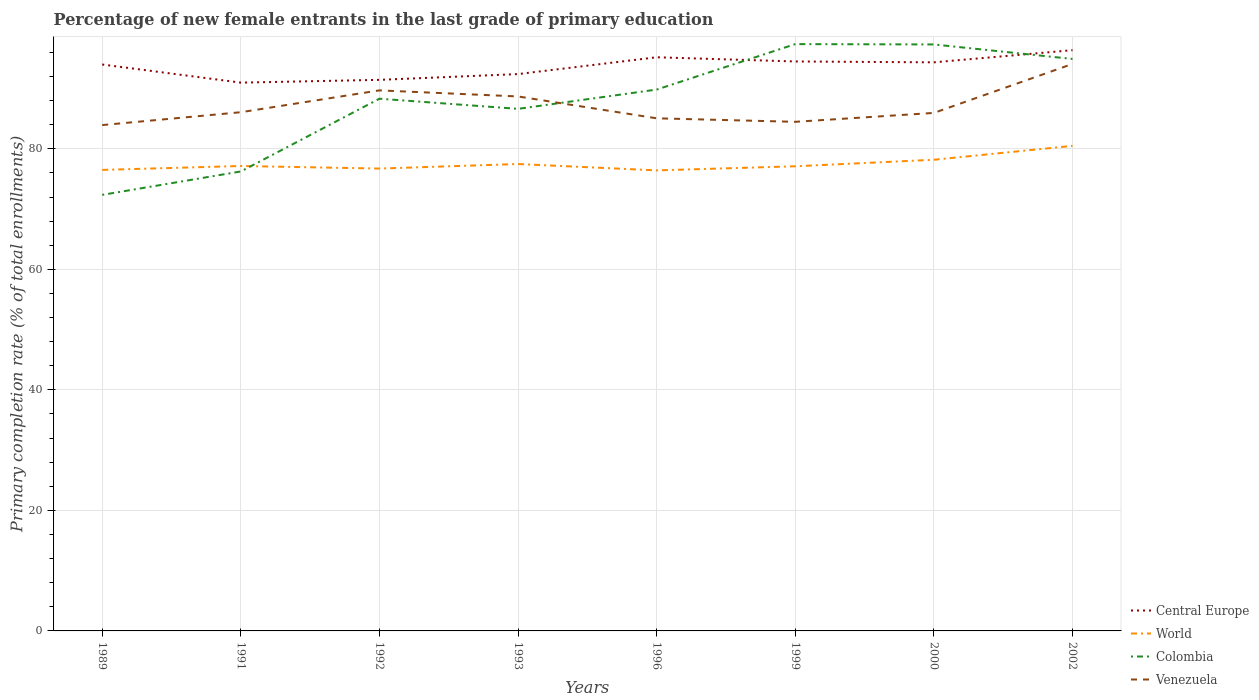How many different coloured lines are there?
Your response must be concise. 4. Across all years, what is the maximum percentage of new female entrants in Central Europe?
Your response must be concise. 90.98. In which year was the percentage of new female entrants in Venezuela maximum?
Your answer should be compact. 1989. What is the total percentage of new female entrants in Central Europe in the graph?
Make the answer very short. 0.7. What is the difference between the highest and the second highest percentage of new female entrants in Central Europe?
Your answer should be very brief. 5.39. What is the difference between the highest and the lowest percentage of new female entrants in Central Europe?
Keep it short and to the point. 5. Is the percentage of new female entrants in Central Europe strictly greater than the percentage of new female entrants in World over the years?
Ensure brevity in your answer.  No. How many years are there in the graph?
Provide a succinct answer. 8. Are the values on the major ticks of Y-axis written in scientific E-notation?
Offer a terse response. No. Does the graph contain any zero values?
Give a very brief answer. No. Does the graph contain grids?
Keep it short and to the point. Yes. How many legend labels are there?
Make the answer very short. 4. How are the legend labels stacked?
Keep it short and to the point. Vertical. What is the title of the graph?
Provide a succinct answer. Percentage of new female entrants in the last grade of primary education. What is the label or title of the X-axis?
Provide a succinct answer. Years. What is the label or title of the Y-axis?
Give a very brief answer. Primary completion rate (% of total enrollments). What is the Primary completion rate (% of total enrollments) in Central Europe in 1989?
Make the answer very short. 93.98. What is the Primary completion rate (% of total enrollments) in World in 1989?
Provide a short and direct response. 76.5. What is the Primary completion rate (% of total enrollments) of Colombia in 1989?
Give a very brief answer. 72.35. What is the Primary completion rate (% of total enrollments) of Venezuela in 1989?
Your response must be concise. 83.93. What is the Primary completion rate (% of total enrollments) in Central Europe in 1991?
Provide a succinct answer. 90.98. What is the Primary completion rate (% of total enrollments) in World in 1991?
Your answer should be very brief. 77.14. What is the Primary completion rate (% of total enrollments) in Colombia in 1991?
Provide a succinct answer. 76.24. What is the Primary completion rate (% of total enrollments) of Venezuela in 1991?
Give a very brief answer. 86.07. What is the Primary completion rate (% of total enrollments) in Central Europe in 1992?
Provide a short and direct response. 91.44. What is the Primary completion rate (% of total enrollments) of World in 1992?
Your answer should be very brief. 76.72. What is the Primary completion rate (% of total enrollments) of Colombia in 1992?
Your response must be concise. 88.31. What is the Primary completion rate (% of total enrollments) of Venezuela in 1992?
Give a very brief answer. 89.69. What is the Primary completion rate (% of total enrollments) of Central Europe in 1993?
Make the answer very short. 92.4. What is the Primary completion rate (% of total enrollments) of World in 1993?
Your answer should be very brief. 77.47. What is the Primary completion rate (% of total enrollments) in Colombia in 1993?
Your response must be concise. 86.63. What is the Primary completion rate (% of total enrollments) in Venezuela in 1993?
Your response must be concise. 88.68. What is the Primary completion rate (% of total enrollments) in Central Europe in 1996?
Offer a very short reply. 95.19. What is the Primary completion rate (% of total enrollments) in World in 1996?
Make the answer very short. 76.42. What is the Primary completion rate (% of total enrollments) of Colombia in 1996?
Make the answer very short. 89.82. What is the Primary completion rate (% of total enrollments) of Venezuela in 1996?
Provide a short and direct response. 85.06. What is the Primary completion rate (% of total enrollments) in Central Europe in 1999?
Your response must be concise. 94.49. What is the Primary completion rate (% of total enrollments) of World in 1999?
Provide a succinct answer. 77.1. What is the Primary completion rate (% of total enrollments) in Colombia in 1999?
Offer a very short reply. 97.37. What is the Primary completion rate (% of total enrollments) in Venezuela in 1999?
Provide a short and direct response. 84.48. What is the Primary completion rate (% of total enrollments) in Central Europe in 2000?
Provide a short and direct response. 94.35. What is the Primary completion rate (% of total enrollments) of World in 2000?
Offer a terse response. 78.18. What is the Primary completion rate (% of total enrollments) of Colombia in 2000?
Ensure brevity in your answer.  97.31. What is the Primary completion rate (% of total enrollments) of Venezuela in 2000?
Your answer should be compact. 85.95. What is the Primary completion rate (% of total enrollments) of Central Europe in 2002?
Provide a short and direct response. 96.36. What is the Primary completion rate (% of total enrollments) in World in 2002?
Offer a terse response. 80.49. What is the Primary completion rate (% of total enrollments) of Colombia in 2002?
Make the answer very short. 94.91. What is the Primary completion rate (% of total enrollments) in Venezuela in 2002?
Your answer should be compact. 94.08. Across all years, what is the maximum Primary completion rate (% of total enrollments) in Central Europe?
Offer a very short reply. 96.36. Across all years, what is the maximum Primary completion rate (% of total enrollments) of World?
Provide a short and direct response. 80.49. Across all years, what is the maximum Primary completion rate (% of total enrollments) of Colombia?
Provide a short and direct response. 97.37. Across all years, what is the maximum Primary completion rate (% of total enrollments) in Venezuela?
Provide a succinct answer. 94.08. Across all years, what is the minimum Primary completion rate (% of total enrollments) of Central Europe?
Your response must be concise. 90.98. Across all years, what is the minimum Primary completion rate (% of total enrollments) of World?
Give a very brief answer. 76.42. Across all years, what is the minimum Primary completion rate (% of total enrollments) in Colombia?
Offer a very short reply. 72.35. Across all years, what is the minimum Primary completion rate (% of total enrollments) of Venezuela?
Provide a succinct answer. 83.93. What is the total Primary completion rate (% of total enrollments) of Central Europe in the graph?
Make the answer very short. 749.18. What is the total Primary completion rate (% of total enrollments) in World in the graph?
Make the answer very short. 620.01. What is the total Primary completion rate (% of total enrollments) of Colombia in the graph?
Offer a terse response. 702.95. What is the total Primary completion rate (% of total enrollments) of Venezuela in the graph?
Your response must be concise. 697.95. What is the difference between the Primary completion rate (% of total enrollments) of Central Europe in 1989 and that in 1991?
Give a very brief answer. 3.01. What is the difference between the Primary completion rate (% of total enrollments) in World in 1989 and that in 1991?
Offer a very short reply. -0.65. What is the difference between the Primary completion rate (% of total enrollments) of Colombia in 1989 and that in 1991?
Give a very brief answer. -3.88. What is the difference between the Primary completion rate (% of total enrollments) in Venezuela in 1989 and that in 1991?
Ensure brevity in your answer.  -2.13. What is the difference between the Primary completion rate (% of total enrollments) of Central Europe in 1989 and that in 1992?
Your response must be concise. 2.54. What is the difference between the Primary completion rate (% of total enrollments) in World in 1989 and that in 1992?
Your response must be concise. -0.22. What is the difference between the Primary completion rate (% of total enrollments) of Colombia in 1989 and that in 1992?
Your response must be concise. -15.96. What is the difference between the Primary completion rate (% of total enrollments) in Venezuela in 1989 and that in 1992?
Keep it short and to the point. -5.76. What is the difference between the Primary completion rate (% of total enrollments) in Central Europe in 1989 and that in 1993?
Keep it short and to the point. 1.59. What is the difference between the Primary completion rate (% of total enrollments) in World in 1989 and that in 1993?
Provide a succinct answer. -0.98. What is the difference between the Primary completion rate (% of total enrollments) in Colombia in 1989 and that in 1993?
Give a very brief answer. -14.27. What is the difference between the Primary completion rate (% of total enrollments) in Venezuela in 1989 and that in 1993?
Your response must be concise. -4.75. What is the difference between the Primary completion rate (% of total enrollments) of Central Europe in 1989 and that in 1996?
Ensure brevity in your answer.  -1.2. What is the difference between the Primary completion rate (% of total enrollments) in World in 1989 and that in 1996?
Give a very brief answer. 0.08. What is the difference between the Primary completion rate (% of total enrollments) in Colombia in 1989 and that in 1996?
Your answer should be very brief. -17.47. What is the difference between the Primary completion rate (% of total enrollments) in Venezuela in 1989 and that in 1996?
Keep it short and to the point. -1.12. What is the difference between the Primary completion rate (% of total enrollments) in Central Europe in 1989 and that in 1999?
Ensure brevity in your answer.  -0.51. What is the difference between the Primary completion rate (% of total enrollments) of World in 1989 and that in 1999?
Offer a terse response. -0.6. What is the difference between the Primary completion rate (% of total enrollments) in Colombia in 1989 and that in 1999?
Your answer should be very brief. -25.01. What is the difference between the Primary completion rate (% of total enrollments) in Venezuela in 1989 and that in 1999?
Provide a succinct answer. -0.54. What is the difference between the Primary completion rate (% of total enrollments) in Central Europe in 1989 and that in 2000?
Offer a terse response. -0.36. What is the difference between the Primary completion rate (% of total enrollments) in World in 1989 and that in 2000?
Give a very brief answer. -1.68. What is the difference between the Primary completion rate (% of total enrollments) of Colombia in 1989 and that in 2000?
Provide a succinct answer. -24.96. What is the difference between the Primary completion rate (% of total enrollments) of Venezuela in 1989 and that in 2000?
Give a very brief answer. -2.02. What is the difference between the Primary completion rate (% of total enrollments) in Central Europe in 1989 and that in 2002?
Keep it short and to the point. -2.38. What is the difference between the Primary completion rate (% of total enrollments) in World in 1989 and that in 2002?
Provide a succinct answer. -3.99. What is the difference between the Primary completion rate (% of total enrollments) of Colombia in 1989 and that in 2002?
Offer a terse response. -22.55. What is the difference between the Primary completion rate (% of total enrollments) of Venezuela in 1989 and that in 2002?
Offer a terse response. -10.14. What is the difference between the Primary completion rate (% of total enrollments) of Central Europe in 1991 and that in 1992?
Your answer should be compact. -0.46. What is the difference between the Primary completion rate (% of total enrollments) of World in 1991 and that in 1992?
Offer a terse response. 0.43. What is the difference between the Primary completion rate (% of total enrollments) in Colombia in 1991 and that in 1992?
Give a very brief answer. -12.07. What is the difference between the Primary completion rate (% of total enrollments) of Venezuela in 1991 and that in 1992?
Offer a terse response. -3.62. What is the difference between the Primary completion rate (% of total enrollments) in Central Europe in 1991 and that in 1993?
Keep it short and to the point. -1.42. What is the difference between the Primary completion rate (% of total enrollments) in World in 1991 and that in 1993?
Provide a short and direct response. -0.33. What is the difference between the Primary completion rate (% of total enrollments) of Colombia in 1991 and that in 1993?
Keep it short and to the point. -10.39. What is the difference between the Primary completion rate (% of total enrollments) in Venezuela in 1991 and that in 1993?
Provide a succinct answer. -2.61. What is the difference between the Primary completion rate (% of total enrollments) in Central Europe in 1991 and that in 1996?
Your answer should be very brief. -4.21. What is the difference between the Primary completion rate (% of total enrollments) of World in 1991 and that in 1996?
Keep it short and to the point. 0.73. What is the difference between the Primary completion rate (% of total enrollments) of Colombia in 1991 and that in 1996?
Keep it short and to the point. -13.58. What is the difference between the Primary completion rate (% of total enrollments) of Central Europe in 1991 and that in 1999?
Make the answer very short. -3.51. What is the difference between the Primary completion rate (% of total enrollments) in World in 1991 and that in 1999?
Make the answer very short. 0.05. What is the difference between the Primary completion rate (% of total enrollments) of Colombia in 1991 and that in 1999?
Offer a terse response. -21.13. What is the difference between the Primary completion rate (% of total enrollments) in Venezuela in 1991 and that in 1999?
Offer a terse response. 1.59. What is the difference between the Primary completion rate (% of total enrollments) of Central Europe in 1991 and that in 2000?
Provide a succinct answer. -3.37. What is the difference between the Primary completion rate (% of total enrollments) in World in 1991 and that in 2000?
Your answer should be compact. -1.04. What is the difference between the Primary completion rate (% of total enrollments) in Colombia in 1991 and that in 2000?
Give a very brief answer. -21.07. What is the difference between the Primary completion rate (% of total enrollments) of Venezuela in 1991 and that in 2000?
Give a very brief answer. 0.12. What is the difference between the Primary completion rate (% of total enrollments) in Central Europe in 1991 and that in 2002?
Give a very brief answer. -5.39. What is the difference between the Primary completion rate (% of total enrollments) in World in 1991 and that in 2002?
Offer a very short reply. -3.34. What is the difference between the Primary completion rate (% of total enrollments) in Colombia in 1991 and that in 2002?
Provide a succinct answer. -18.67. What is the difference between the Primary completion rate (% of total enrollments) in Venezuela in 1991 and that in 2002?
Your answer should be compact. -8.01. What is the difference between the Primary completion rate (% of total enrollments) of Central Europe in 1992 and that in 1993?
Provide a short and direct response. -0.96. What is the difference between the Primary completion rate (% of total enrollments) in World in 1992 and that in 1993?
Your response must be concise. -0.75. What is the difference between the Primary completion rate (% of total enrollments) of Colombia in 1992 and that in 1993?
Provide a short and direct response. 1.68. What is the difference between the Primary completion rate (% of total enrollments) in Venezuela in 1992 and that in 1993?
Provide a succinct answer. 1.01. What is the difference between the Primary completion rate (% of total enrollments) in Central Europe in 1992 and that in 1996?
Provide a short and direct response. -3.75. What is the difference between the Primary completion rate (% of total enrollments) of World in 1992 and that in 1996?
Give a very brief answer. 0.3. What is the difference between the Primary completion rate (% of total enrollments) in Colombia in 1992 and that in 1996?
Provide a succinct answer. -1.51. What is the difference between the Primary completion rate (% of total enrollments) in Venezuela in 1992 and that in 1996?
Your answer should be very brief. 4.63. What is the difference between the Primary completion rate (% of total enrollments) of Central Europe in 1992 and that in 1999?
Provide a succinct answer. -3.05. What is the difference between the Primary completion rate (% of total enrollments) in World in 1992 and that in 1999?
Make the answer very short. -0.38. What is the difference between the Primary completion rate (% of total enrollments) of Colombia in 1992 and that in 1999?
Your answer should be compact. -9.06. What is the difference between the Primary completion rate (% of total enrollments) in Venezuela in 1992 and that in 1999?
Your response must be concise. 5.22. What is the difference between the Primary completion rate (% of total enrollments) of Central Europe in 1992 and that in 2000?
Your response must be concise. -2.91. What is the difference between the Primary completion rate (% of total enrollments) in World in 1992 and that in 2000?
Your answer should be very brief. -1.46. What is the difference between the Primary completion rate (% of total enrollments) of Colombia in 1992 and that in 2000?
Provide a succinct answer. -9. What is the difference between the Primary completion rate (% of total enrollments) of Venezuela in 1992 and that in 2000?
Offer a very short reply. 3.74. What is the difference between the Primary completion rate (% of total enrollments) of Central Europe in 1992 and that in 2002?
Your response must be concise. -4.92. What is the difference between the Primary completion rate (% of total enrollments) in World in 1992 and that in 2002?
Your answer should be compact. -3.77. What is the difference between the Primary completion rate (% of total enrollments) of Colombia in 1992 and that in 2002?
Make the answer very short. -6.6. What is the difference between the Primary completion rate (% of total enrollments) of Venezuela in 1992 and that in 2002?
Offer a very short reply. -4.39. What is the difference between the Primary completion rate (% of total enrollments) of Central Europe in 1993 and that in 1996?
Provide a succinct answer. -2.79. What is the difference between the Primary completion rate (% of total enrollments) in World in 1993 and that in 1996?
Provide a succinct answer. 1.05. What is the difference between the Primary completion rate (% of total enrollments) in Colombia in 1993 and that in 1996?
Give a very brief answer. -3.2. What is the difference between the Primary completion rate (% of total enrollments) of Venezuela in 1993 and that in 1996?
Offer a very short reply. 3.62. What is the difference between the Primary completion rate (% of total enrollments) in Central Europe in 1993 and that in 1999?
Your answer should be very brief. -2.09. What is the difference between the Primary completion rate (% of total enrollments) of World in 1993 and that in 1999?
Your answer should be very brief. 0.37. What is the difference between the Primary completion rate (% of total enrollments) in Colombia in 1993 and that in 1999?
Offer a terse response. -10.74. What is the difference between the Primary completion rate (% of total enrollments) of Venezuela in 1993 and that in 1999?
Keep it short and to the point. 4.21. What is the difference between the Primary completion rate (% of total enrollments) of Central Europe in 1993 and that in 2000?
Your answer should be compact. -1.95. What is the difference between the Primary completion rate (% of total enrollments) in World in 1993 and that in 2000?
Your answer should be very brief. -0.71. What is the difference between the Primary completion rate (% of total enrollments) in Colombia in 1993 and that in 2000?
Keep it short and to the point. -10.69. What is the difference between the Primary completion rate (% of total enrollments) in Venezuela in 1993 and that in 2000?
Offer a terse response. 2.73. What is the difference between the Primary completion rate (% of total enrollments) in Central Europe in 1993 and that in 2002?
Keep it short and to the point. -3.97. What is the difference between the Primary completion rate (% of total enrollments) of World in 1993 and that in 2002?
Offer a very short reply. -3.02. What is the difference between the Primary completion rate (% of total enrollments) in Colombia in 1993 and that in 2002?
Your answer should be very brief. -8.28. What is the difference between the Primary completion rate (% of total enrollments) in Venezuela in 1993 and that in 2002?
Your answer should be very brief. -5.4. What is the difference between the Primary completion rate (% of total enrollments) of Central Europe in 1996 and that in 1999?
Make the answer very short. 0.7. What is the difference between the Primary completion rate (% of total enrollments) in World in 1996 and that in 1999?
Give a very brief answer. -0.68. What is the difference between the Primary completion rate (% of total enrollments) in Colombia in 1996 and that in 1999?
Make the answer very short. -7.54. What is the difference between the Primary completion rate (% of total enrollments) in Venezuela in 1996 and that in 1999?
Offer a terse response. 0.58. What is the difference between the Primary completion rate (% of total enrollments) of Central Europe in 1996 and that in 2000?
Offer a terse response. 0.84. What is the difference between the Primary completion rate (% of total enrollments) of World in 1996 and that in 2000?
Offer a terse response. -1.76. What is the difference between the Primary completion rate (% of total enrollments) of Colombia in 1996 and that in 2000?
Offer a terse response. -7.49. What is the difference between the Primary completion rate (% of total enrollments) in Venezuela in 1996 and that in 2000?
Ensure brevity in your answer.  -0.89. What is the difference between the Primary completion rate (% of total enrollments) in Central Europe in 1996 and that in 2002?
Offer a very short reply. -1.18. What is the difference between the Primary completion rate (% of total enrollments) of World in 1996 and that in 2002?
Make the answer very short. -4.07. What is the difference between the Primary completion rate (% of total enrollments) of Colombia in 1996 and that in 2002?
Ensure brevity in your answer.  -5.08. What is the difference between the Primary completion rate (% of total enrollments) of Venezuela in 1996 and that in 2002?
Provide a short and direct response. -9.02. What is the difference between the Primary completion rate (% of total enrollments) in Central Europe in 1999 and that in 2000?
Ensure brevity in your answer.  0.14. What is the difference between the Primary completion rate (% of total enrollments) in World in 1999 and that in 2000?
Give a very brief answer. -1.08. What is the difference between the Primary completion rate (% of total enrollments) of Colombia in 1999 and that in 2000?
Offer a very short reply. 0.06. What is the difference between the Primary completion rate (% of total enrollments) in Venezuela in 1999 and that in 2000?
Your response must be concise. -1.48. What is the difference between the Primary completion rate (% of total enrollments) in Central Europe in 1999 and that in 2002?
Offer a terse response. -1.87. What is the difference between the Primary completion rate (% of total enrollments) in World in 1999 and that in 2002?
Make the answer very short. -3.39. What is the difference between the Primary completion rate (% of total enrollments) of Colombia in 1999 and that in 2002?
Your answer should be very brief. 2.46. What is the difference between the Primary completion rate (% of total enrollments) in Venezuela in 1999 and that in 2002?
Offer a terse response. -9.6. What is the difference between the Primary completion rate (% of total enrollments) in Central Europe in 2000 and that in 2002?
Your answer should be compact. -2.02. What is the difference between the Primary completion rate (% of total enrollments) in World in 2000 and that in 2002?
Give a very brief answer. -2.31. What is the difference between the Primary completion rate (% of total enrollments) of Colombia in 2000 and that in 2002?
Make the answer very short. 2.4. What is the difference between the Primary completion rate (% of total enrollments) in Venezuela in 2000 and that in 2002?
Keep it short and to the point. -8.12. What is the difference between the Primary completion rate (% of total enrollments) in Central Europe in 1989 and the Primary completion rate (% of total enrollments) in World in 1991?
Your answer should be compact. 16.84. What is the difference between the Primary completion rate (% of total enrollments) in Central Europe in 1989 and the Primary completion rate (% of total enrollments) in Colombia in 1991?
Make the answer very short. 17.74. What is the difference between the Primary completion rate (% of total enrollments) in Central Europe in 1989 and the Primary completion rate (% of total enrollments) in Venezuela in 1991?
Your response must be concise. 7.91. What is the difference between the Primary completion rate (% of total enrollments) in World in 1989 and the Primary completion rate (% of total enrollments) in Colombia in 1991?
Your answer should be very brief. 0.26. What is the difference between the Primary completion rate (% of total enrollments) in World in 1989 and the Primary completion rate (% of total enrollments) in Venezuela in 1991?
Your answer should be very brief. -9.57. What is the difference between the Primary completion rate (% of total enrollments) in Colombia in 1989 and the Primary completion rate (% of total enrollments) in Venezuela in 1991?
Keep it short and to the point. -13.71. What is the difference between the Primary completion rate (% of total enrollments) of Central Europe in 1989 and the Primary completion rate (% of total enrollments) of World in 1992?
Provide a short and direct response. 17.27. What is the difference between the Primary completion rate (% of total enrollments) in Central Europe in 1989 and the Primary completion rate (% of total enrollments) in Colombia in 1992?
Give a very brief answer. 5.67. What is the difference between the Primary completion rate (% of total enrollments) of Central Europe in 1989 and the Primary completion rate (% of total enrollments) of Venezuela in 1992?
Ensure brevity in your answer.  4.29. What is the difference between the Primary completion rate (% of total enrollments) in World in 1989 and the Primary completion rate (% of total enrollments) in Colombia in 1992?
Provide a succinct answer. -11.82. What is the difference between the Primary completion rate (% of total enrollments) of World in 1989 and the Primary completion rate (% of total enrollments) of Venezuela in 1992?
Provide a succinct answer. -13.2. What is the difference between the Primary completion rate (% of total enrollments) of Colombia in 1989 and the Primary completion rate (% of total enrollments) of Venezuela in 1992?
Provide a short and direct response. -17.34. What is the difference between the Primary completion rate (% of total enrollments) in Central Europe in 1989 and the Primary completion rate (% of total enrollments) in World in 1993?
Keep it short and to the point. 16.51. What is the difference between the Primary completion rate (% of total enrollments) of Central Europe in 1989 and the Primary completion rate (% of total enrollments) of Colombia in 1993?
Keep it short and to the point. 7.36. What is the difference between the Primary completion rate (% of total enrollments) of World in 1989 and the Primary completion rate (% of total enrollments) of Colombia in 1993?
Your response must be concise. -10.13. What is the difference between the Primary completion rate (% of total enrollments) of World in 1989 and the Primary completion rate (% of total enrollments) of Venezuela in 1993?
Your answer should be very brief. -12.19. What is the difference between the Primary completion rate (% of total enrollments) of Colombia in 1989 and the Primary completion rate (% of total enrollments) of Venezuela in 1993?
Offer a terse response. -16.33. What is the difference between the Primary completion rate (% of total enrollments) in Central Europe in 1989 and the Primary completion rate (% of total enrollments) in World in 1996?
Give a very brief answer. 17.57. What is the difference between the Primary completion rate (% of total enrollments) of Central Europe in 1989 and the Primary completion rate (% of total enrollments) of Colombia in 1996?
Your answer should be compact. 4.16. What is the difference between the Primary completion rate (% of total enrollments) in Central Europe in 1989 and the Primary completion rate (% of total enrollments) in Venezuela in 1996?
Your answer should be compact. 8.92. What is the difference between the Primary completion rate (% of total enrollments) of World in 1989 and the Primary completion rate (% of total enrollments) of Colombia in 1996?
Your response must be concise. -13.33. What is the difference between the Primary completion rate (% of total enrollments) in World in 1989 and the Primary completion rate (% of total enrollments) in Venezuela in 1996?
Your answer should be compact. -8.56. What is the difference between the Primary completion rate (% of total enrollments) of Colombia in 1989 and the Primary completion rate (% of total enrollments) of Venezuela in 1996?
Your answer should be compact. -12.7. What is the difference between the Primary completion rate (% of total enrollments) of Central Europe in 1989 and the Primary completion rate (% of total enrollments) of World in 1999?
Provide a succinct answer. 16.89. What is the difference between the Primary completion rate (% of total enrollments) in Central Europe in 1989 and the Primary completion rate (% of total enrollments) in Colombia in 1999?
Give a very brief answer. -3.39. What is the difference between the Primary completion rate (% of total enrollments) of Central Europe in 1989 and the Primary completion rate (% of total enrollments) of Venezuela in 1999?
Your answer should be very brief. 9.51. What is the difference between the Primary completion rate (% of total enrollments) of World in 1989 and the Primary completion rate (% of total enrollments) of Colombia in 1999?
Give a very brief answer. -20.87. What is the difference between the Primary completion rate (% of total enrollments) in World in 1989 and the Primary completion rate (% of total enrollments) in Venezuela in 1999?
Your response must be concise. -7.98. What is the difference between the Primary completion rate (% of total enrollments) of Colombia in 1989 and the Primary completion rate (% of total enrollments) of Venezuela in 1999?
Your response must be concise. -12.12. What is the difference between the Primary completion rate (% of total enrollments) of Central Europe in 1989 and the Primary completion rate (% of total enrollments) of World in 2000?
Your answer should be very brief. 15.8. What is the difference between the Primary completion rate (% of total enrollments) in Central Europe in 1989 and the Primary completion rate (% of total enrollments) in Colombia in 2000?
Offer a terse response. -3.33. What is the difference between the Primary completion rate (% of total enrollments) in Central Europe in 1989 and the Primary completion rate (% of total enrollments) in Venezuela in 2000?
Keep it short and to the point. 8.03. What is the difference between the Primary completion rate (% of total enrollments) in World in 1989 and the Primary completion rate (% of total enrollments) in Colombia in 2000?
Your answer should be compact. -20.82. What is the difference between the Primary completion rate (% of total enrollments) of World in 1989 and the Primary completion rate (% of total enrollments) of Venezuela in 2000?
Your answer should be compact. -9.46. What is the difference between the Primary completion rate (% of total enrollments) in Colombia in 1989 and the Primary completion rate (% of total enrollments) in Venezuela in 2000?
Keep it short and to the point. -13.6. What is the difference between the Primary completion rate (% of total enrollments) in Central Europe in 1989 and the Primary completion rate (% of total enrollments) in World in 2002?
Make the answer very short. 13.5. What is the difference between the Primary completion rate (% of total enrollments) of Central Europe in 1989 and the Primary completion rate (% of total enrollments) of Colombia in 2002?
Ensure brevity in your answer.  -0.92. What is the difference between the Primary completion rate (% of total enrollments) of Central Europe in 1989 and the Primary completion rate (% of total enrollments) of Venezuela in 2002?
Keep it short and to the point. -0.1. What is the difference between the Primary completion rate (% of total enrollments) of World in 1989 and the Primary completion rate (% of total enrollments) of Colombia in 2002?
Provide a succinct answer. -18.41. What is the difference between the Primary completion rate (% of total enrollments) of World in 1989 and the Primary completion rate (% of total enrollments) of Venezuela in 2002?
Provide a succinct answer. -17.58. What is the difference between the Primary completion rate (% of total enrollments) of Colombia in 1989 and the Primary completion rate (% of total enrollments) of Venezuela in 2002?
Provide a short and direct response. -21.72. What is the difference between the Primary completion rate (% of total enrollments) in Central Europe in 1991 and the Primary completion rate (% of total enrollments) in World in 1992?
Your response must be concise. 14.26. What is the difference between the Primary completion rate (% of total enrollments) of Central Europe in 1991 and the Primary completion rate (% of total enrollments) of Colombia in 1992?
Your answer should be compact. 2.67. What is the difference between the Primary completion rate (% of total enrollments) in Central Europe in 1991 and the Primary completion rate (% of total enrollments) in Venezuela in 1992?
Make the answer very short. 1.28. What is the difference between the Primary completion rate (% of total enrollments) of World in 1991 and the Primary completion rate (% of total enrollments) of Colombia in 1992?
Give a very brief answer. -11.17. What is the difference between the Primary completion rate (% of total enrollments) in World in 1991 and the Primary completion rate (% of total enrollments) in Venezuela in 1992?
Ensure brevity in your answer.  -12.55. What is the difference between the Primary completion rate (% of total enrollments) of Colombia in 1991 and the Primary completion rate (% of total enrollments) of Venezuela in 1992?
Provide a succinct answer. -13.45. What is the difference between the Primary completion rate (% of total enrollments) of Central Europe in 1991 and the Primary completion rate (% of total enrollments) of World in 1993?
Offer a terse response. 13.51. What is the difference between the Primary completion rate (% of total enrollments) in Central Europe in 1991 and the Primary completion rate (% of total enrollments) in Colombia in 1993?
Your answer should be very brief. 4.35. What is the difference between the Primary completion rate (% of total enrollments) in Central Europe in 1991 and the Primary completion rate (% of total enrollments) in Venezuela in 1993?
Give a very brief answer. 2.29. What is the difference between the Primary completion rate (% of total enrollments) in World in 1991 and the Primary completion rate (% of total enrollments) in Colombia in 1993?
Ensure brevity in your answer.  -9.48. What is the difference between the Primary completion rate (% of total enrollments) in World in 1991 and the Primary completion rate (% of total enrollments) in Venezuela in 1993?
Make the answer very short. -11.54. What is the difference between the Primary completion rate (% of total enrollments) in Colombia in 1991 and the Primary completion rate (% of total enrollments) in Venezuela in 1993?
Provide a succinct answer. -12.44. What is the difference between the Primary completion rate (% of total enrollments) in Central Europe in 1991 and the Primary completion rate (% of total enrollments) in World in 1996?
Your answer should be very brief. 14.56. What is the difference between the Primary completion rate (% of total enrollments) of Central Europe in 1991 and the Primary completion rate (% of total enrollments) of Colombia in 1996?
Keep it short and to the point. 1.15. What is the difference between the Primary completion rate (% of total enrollments) of Central Europe in 1991 and the Primary completion rate (% of total enrollments) of Venezuela in 1996?
Your answer should be compact. 5.92. What is the difference between the Primary completion rate (% of total enrollments) in World in 1991 and the Primary completion rate (% of total enrollments) in Colombia in 1996?
Your answer should be compact. -12.68. What is the difference between the Primary completion rate (% of total enrollments) in World in 1991 and the Primary completion rate (% of total enrollments) in Venezuela in 1996?
Your answer should be very brief. -7.91. What is the difference between the Primary completion rate (% of total enrollments) of Colombia in 1991 and the Primary completion rate (% of total enrollments) of Venezuela in 1996?
Keep it short and to the point. -8.82. What is the difference between the Primary completion rate (% of total enrollments) in Central Europe in 1991 and the Primary completion rate (% of total enrollments) in World in 1999?
Offer a terse response. 13.88. What is the difference between the Primary completion rate (% of total enrollments) in Central Europe in 1991 and the Primary completion rate (% of total enrollments) in Colombia in 1999?
Provide a succinct answer. -6.39. What is the difference between the Primary completion rate (% of total enrollments) in Central Europe in 1991 and the Primary completion rate (% of total enrollments) in Venezuela in 1999?
Provide a succinct answer. 6.5. What is the difference between the Primary completion rate (% of total enrollments) in World in 1991 and the Primary completion rate (% of total enrollments) in Colombia in 1999?
Your answer should be compact. -20.22. What is the difference between the Primary completion rate (% of total enrollments) of World in 1991 and the Primary completion rate (% of total enrollments) of Venezuela in 1999?
Make the answer very short. -7.33. What is the difference between the Primary completion rate (% of total enrollments) in Colombia in 1991 and the Primary completion rate (% of total enrollments) in Venezuela in 1999?
Ensure brevity in your answer.  -8.24. What is the difference between the Primary completion rate (% of total enrollments) of Central Europe in 1991 and the Primary completion rate (% of total enrollments) of World in 2000?
Your response must be concise. 12.8. What is the difference between the Primary completion rate (% of total enrollments) in Central Europe in 1991 and the Primary completion rate (% of total enrollments) in Colombia in 2000?
Make the answer very short. -6.34. What is the difference between the Primary completion rate (% of total enrollments) in Central Europe in 1991 and the Primary completion rate (% of total enrollments) in Venezuela in 2000?
Give a very brief answer. 5.02. What is the difference between the Primary completion rate (% of total enrollments) of World in 1991 and the Primary completion rate (% of total enrollments) of Colombia in 2000?
Offer a terse response. -20.17. What is the difference between the Primary completion rate (% of total enrollments) in World in 1991 and the Primary completion rate (% of total enrollments) in Venezuela in 2000?
Keep it short and to the point. -8.81. What is the difference between the Primary completion rate (% of total enrollments) in Colombia in 1991 and the Primary completion rate (% of total enrollments) in Venezuela in 2000?
Your answer should be compact. -9.71. What is the difference between the Primary completion rate (% of total enrollments) of Central Europe in 1991 and the Primary completion rate (% of total enrollments) of World in 2002?
Give a very brief answer. 10.49. What is the difference between the Primary completion rate (% of total enrollments) in Central Europe in 1991 and the Primary completion rate (% of total enrollments) in Colombia in 2002?
Keep it short and to the point. -3.93. What is the difference between the Primary completion rate (% of total enrollments) of Central Europe in 1991 and the Primary completion rate (% of total enrollments) of Venezuela in 2002?
Give a very brief answer. -3.1. What is the difference between the Primary completion rate (% of total enrollments) of World in 1991 and the Primary completion rate (% of total enrollments) of Colombia in 2002?
Your answer should be compact. -17.76. What is the difference between the Primary completion rate (% of total enrollments) in World in 1991 and the Primary completion rate (% of total enrollments) in Venezuela in 2002?
Provide a succinct answer. -16.93. What is the difference between the Primary completion rate (% of total enrollments) in Colombia in 1991 and the Primary completion rate (% of total enrollments) in Venezuela in 2002?
Make the answer very short. -17.84. What is the difference between the Primary completion rate (% of total enrollments) in Central Europe in 1992 and the Primary completion rate (% of total enrollments) in World in 1993?
Your answer should be compact. 13.97. What is the difference between the Primary completion rate (% of total enrollments) in Central Europe in 1992 and the Primary completion rate (% of total enrollments) in Colombia in 1993?
Your response must be concise. 4.81. What is the difference between the Primary completion rate (% of total enrollments) of Central Europe in 1992 and the Primary completion rate (% of total enrollments) of Venezuela in 1993?
Give a very brief answer. 2.76. What is the difference between the Primary completion rate (% of total enrollments) of World in 1992 and the Primary completion rate (% of total enrollments) of Colombia in 1993?
Provide a succinct answer. -9.91. What is the difference between the Primary completion rate (% of total enrollments) in World in 1992 and the Primary completion rate (% of total enrollments) in Venezuela in 1993?
Provide a short and direct response. -11.96. What is the difference between the Primary completion rate (% of total enrollments) of Colombia in 1992 and the Primary completion rate (% of total enrollments) of Venezuela in 1993?
Offer a very short reply. -0.37. What is the difference between the Primary completion rate (% of total enrollments) of Central Europe in 1992 and the Primary completion rate (% of total enrollments) of World in 1996?
Give a very brief answer. 15.02. What is the difference between the Primary completion rate (% of total enrollments) of Central Europe in 1992 and the Primary completion rate (% of total enrollments) of Colombia in 1996?
Keep it short and to the point. 1.62. What is the difference between the Primary completion rate (% of total enrollments) of Central Europe in 1992 and the Primary completion rate (% of total enrollments) of Venezuela in 1996?
Your response must be concise. 6.38. What is the difference between the Primary completion rate (% of total enrollments) of World in 1992 and the Primary completion rate (% of total enrollments) of Colombia in 1996?
Give a very brief answer. -13.11. What is the difference between the Primary completion rate (% of total enrollments) of World in 1992 and the Primary completion rate (% of total enrollments) of Venezuela in 1996?
Provide a short and direct response. -8.34. What is the difference between the Primary completion rate (% of total enrollments) in Colombia in 1992 and the Primary completion rate (% of total enrollments) in Venezuela in 1996?
Your answer should be compact. 3.25. What is the difference between the Primary completion rate (% of total enrollments) of Central Europe in 1992 and the Primary completion rate (% of total enrollments) of World in 1999?
Your answer should be compact. 14.34. What is the difference between the Primary completion rate (% of total enrollments) in Central Europe in 1992 and the Primary completion rate (% of total enrollments) in Colombia in 1999?
Your answer should be compact. -5.93. What is the difference between the Primary completion rate (% of total enrollments) in Central Europe in 1992 and the Primary completion rate (% of total enrollments) in Venezuela in 1999?
Your answer should be very brief. 6.96. What is the difference between the Primary completion rate (% of total enrollments) in World in 1992 and the Primary completion rate (% of total enrollments) in Colombia in 1999?
Your answer should be very brief. -20.65. What is the difference between the Primary completion rate (% of total enrollments) of World in 1992 and the Primary completion rate (% of total enrollments) of Venezuela in 1999?
Offer a terse response. -7.76. What is the difference between the Primary completion rate (% of total enrollments) in Colombia in 1992 and the Primary completion rate (% of total enrollments) in Venezuela in 1999?
Your answer should be very brief. 3.84. What is the difference between the Primary completion rate (% of total enrollments) in Central Europe in 1992 and the Primary completion rate (% of total enrollments) in World in 2000?
Keep it short and to the point. 13.26. What is the difference between the Primary completion rate (% of total enrollments) of Central Europe in 1992 and the Primary completion rate (% of total enrollments) of Colombia in 2000?
Provide a short and direct response. -5.87. What is the difference between the Primary completion rate (% of total enrollments) of Central Europe in 1992 and the Primary completion rate (% of total enrollments) of Venezuela in 2000?
Make the answer very short. 5.49. What is the difference between the Primary completion rate (% of total enrollments) of World in 1992 and the Primary completion rate (% of total enrollments) of Colombia in 2000?
Offer a very short reply. -20.59. What is the difference between the Primary completion rate (% of total enrollments) of World in 1992 and the Primary completion rate (% of total enrollments) of Venezuela in 2000?
Provide a short and direct response. -9.24. What is the difference between the Primary completion rate (% of total enrollments) in Colombia in 1992 and the Primary completion rate (% of total enrollments) in Venezuela in 2000?
Your answer should be very brief. 2.36. What is the difference between the Primary completion rate (% of total enrollments) of Central Europe in 1992 and the Primary completion rate (% of total enrollments) of World in 2002?
Ensure brevity in your answer.  10.95. What is the difference between the Primary completion rate (% of total enrollments) in Central Europe in 1992 and the Primary completion rate (% of total enrollments) in Colombia in 2002?
Make the answer very short. -3.47. What is the difference between the Primary completion rate (% of total enrollments) in Central Europe in 1992 and the Primary completion rate (% of total enrollments) in Venezuela in 2002?
Keep it short and to the point. -2.64. What is the difference between the Primary completion rate (% of total enrollments) of World in 1992 and the Primary completion rate (% of total enrollments) of Colombia in 2002?
Make the answer very short. -18.19. What is the difference between the Primary completion rate (% of total enrollments) in World in 1992 and the Primary completion rate (% of total enrollments) in Venezuela in 2002?
Your answer should be very brief. -17.36. What is the difference between the Primary completion rate (% of total enrollments) of Colombia in 1992 and the Primary completion rate (% of total enrollments) of Venezuela in 2002?
Offer a very short reply. -5.77. What is the difference between the Primary completion rate (% of total enrollments) in Central Europe in 1993 and the Primary completion rate (% of total enrollments) in World in 1996?
Offer a very short reply. 15.98. What is the difference between the Primary completion rate (% of total enrollments) of Central Europe in 1993 and the Primary completion rate (% of total enrollments) of Colombia in 1996?
Offer a terse response. 2.57. What is the difference between the Primary completion rate (% of total enrollments) of Central Europe in 1993 and the Primary completion rate (% of total enrollments) of Venezuela in 1996?
Give a very brief answer. 7.34. What is the difference between the Primary completion rate (% of total enrollments) in World in 1993 and the Primary completion rate (% of total enrollments) in Colombia in 1996?
Your response must be concise. -12.35. What is the difference between the Primary completion rate (% of total enrollments) of World in 1993 and the Primary completion rate (% of total enrollments) of Venezuela in 1996?
Offer a terse response. -7.59. What is the difference between the Primary completion rate (% of total enrollments) in Colombia in 1993 and the Primary completion rate (% of total enrollments) in Venezuela in 1996?
Your answer should be compact. 1.57. What is the difference between the Primary completion rate (% of total enrollments) of Central Europe in 1993 and the Primary completion rate (% of total enrollments) of World in 1999?
Offer a terse response. 15.3. What is the difference between the Primary completion rate (% of total enrollments) in Central Europe in 1993 and the Primary completion rate (% of total enrollments) in Colombia in 1999?
Offer a terse response. -4.97. What is the difference between the Primary completion rate (% of total enrollments) of Central Europe in 1993 and the Primary completion rate (% of total enrollments) of Venezuela in 1999?
Give a very brief answer. 7.92. What is the difference between the Primary completion rate (% of total enrollments) in World in 1993 and the Primary completion rate (% of total enrollments) in Colombia in 1999?
Give a very brief answer. -19.9. What is the difference between the Primary completion rate (% of total enrollments) of World in 1993 and the Primary completion rate (% of total enrollments) of Venezuela in 1999?
Your answer should be very brief. -7. What is the difference between the Primary completion rate (% of total enrollments) in Colombia in 1993 and the Primary completion rate (% of total enrollments) in Venezuela in 1999?
Your answer should be compact. 2.15. What is the difference between the Primary completion rate (% of total enrollments) in Central Europe in 1993 and the Primary completion rate (% of total enrollments) in World in 2000?
Give a very brief answer. 14.22. What is the difference between the Primary completion rate (% of total enrollments) of Central Europe in 1993 and the Primary completion rate (% of total enrollments) of Colombia in 2000?
Your response must be concise. -4.92. What is the difference between the Primary completion rate (% of total enrollments) in Central Europe in 1993 and the Primary completion rate (% of total enrollments) in Venezuela in 2000?
Provide a succinct answer. 6.44. What is the difference between the Primary completion rate (% of total enrollments) in World in 1993 and the Primary completion rate (% of total enrollments) in Colombia in 2000?
Your response must be concise. -19.84. What is the difference between the Primary completion rate (% of total enrollments) in World in 1993 and the Primary completion rate (% of total enrollments) in Venezuela in 2000?
Provide a succinct answer. -8.48. What is the difference between the Primary completion rate (% of total enrollments) of Colombia in 1993 and the Primary completion rate (% of total enrollments) of Venezuela in 2000?
Ensure brevity in your answer.  0.67. What is the difference between the Primary completion rate (% of total enrollments) in Central Europe in 1993 and the Primary completion rate (% of total enrollments) in World in 2002?
Your response must be concise. 11.91. What is the difference between the Primary completion rate (% of total enrollments) in Central Europe in 1993 and the Primary completion rate (% of total enrollments) in Colombia in 2002?
Provide a succinct answer. -2.51. What is the difference between the Primary completion rate (% of total enrollments) in Central Europe in 1993 and the Primary completion rate (% of total enrollments) in Venezuela in 2002?
Make the answer very short. -1.68. What is the difference between the Primary completion rate (% of total enrollments) in World in 1993 and the Primary completion rate (% of total enrollments) in Colombia in 2002?
Provide a short and direct response. -17.44. What is the difference between the Primary completion rate (% of total enrollments) of World in 1993 and the Primary completion rate (% of total enrollments) of Venezuela in 2002?
Keep it short and to the point. -16.61. What is the difference between the Primary completion rate (% of total enrollments) in Colombia in 1993 and the Primary completion rate (% of total enrollments) in Venezuela in 2002?
Provide a succinct answer. -7.45. What is the difference between the Primary completion rate (% of total enrollments) of Central Europe in 1996 and the Primary completion rate (% of total enrollments) of World in 1999?
Give a very brief answer. 18.09. What is the difference between the Primary completion rate (% of total enrollments) in Central Europe in 1996 and the Primary completion rate (% of total enrollments) in Colombia in 1999?
Your answer should be compact. -2.18. What is the difference between the Primary completion rate (% of total enrollments) of Central Europe in 1996 and the Primary completion rate (% of total enrollments) of Venezuela in 1999?
Provide a short and direct response. 10.71. What is the difference between the Primary completion rate (% of total enrollments) of World in 1996 and the Primary completion rate (% of total enrollments) of Colombia in 1999?
Provide a succinct answer. -20.95. What is the difference between the Primary completion rate (% of total enrollments) of World in 1996 and the Primary completion rate (% of total enrollments) of Venezuela in 1999?
Offer a terse response. -8.06. What is the difference between the Primary completion rate (% of total enrollments) in Colombia in 1996 and the Primary completion rate (% of total enrollments) in Venezuela in 1999?
Your response must be concise. 5.35. What is the difference between the Primary completion rate (% of total enrollments) in Central Europe in 1996 and the Primary completion rate (% of total enrollments) in World in 2000?
Your answer should be compact. 17.01. What is the difference between the Primary completion rate (% of total enrollments) of Central Europe in 1996 and the Primary completion rate (% of total enrollments) of Colombia in 2000?
Your answer should be very brief. -2.13. What is the difference between the Primary completion rate (% of total enrollments) of Central Europe in 1996 and the Primary completion rate (% of total enrollments) of Venezuela in 2000?
Offer a terse response. 9.23. What is the difference between the Primary completion rate (% of total enrollments) in World in 1996 and the Primary completion rate (% of total enrollments) in Colombia in 2000?
Offer a very short reply. -20.9. What is the difference between the Primary completion rate (% of total enrollments) in World in 1996 and the Primary completion rate (% of total enrollments) in Venezuela in 2000?
Offer a terse response. -9.54. What is the difference between the Primary completion rate (% of total enrollments) in Colombia in 1996 and the Primary completion rate (% of total enrollments) in Venezuela in 2000?
Provide a short and direct response. 3.87. What is the difference between the Primary completion rate (% of total enrollments) in Central Europe in 1996 and the Primary completion rate (% of total enrollments) in World in 2002?
Ensure brevity in your answer.  14.7. What is the difference between the Primary completion rate (% of total enrollments) of Central Europe in 1996 and the Primary completion rate (% of total enrollments) of Colombia in 2002?
Give a very brief answer. 0.28. What is the difference between the Primary completion rate (% of total enrollments) of Central Europe in 1996 and the Primary completion rate (% of total enrollments) of Venezuela in 2002?
Your response must be concise. 1.11. What is the difference between the Primary completion rate (% of total enrollments) of World in 1996 and the Primary completion rate (% of total enrollments) of Colombia in 2002?
Offer a very short reply. -18.49. What is the difference between the Primary completion rate (% of total enrollments) of World in 1996 and the Primary completion rate (% of total enrollments) of Venezuela in 2002?
Your response must be concise. -17.66. What is the difference between the Primary completion rate (% of total enrollments) in Colombia in 1996 and the Primary completion rate (% of total enrollments) in Venezuela in 2002?
Provide a succinct answer. -4.25. What is the difference between the Primary completion rate (% of total enrollments) of Central Europe in 1999 and the Primary completion rate (% of total enrollments) of World in 2000?
Provide a short and direct response. 16.31. What is the difference between the Primary completion rate (% of total enrollments) of Central Europe in 1999 and the Primary completion rate (% of total enrollments) of Colombia in 2000?
Your answer should be compact. -2.82. What is the difference between the Primary completion rate (% of total enrollments) in Central Europe in 1999 and the Primary completion rate (% of total enrollments) in Venezuela in 2000?
Ensure brevity in your answer.  8.54. What is the difference between the Primary completion rate (% of total enrollments) of World in 1999 and the Primary completion rate (% of total enrollments) of Colombia in 2000?
Keep it short and to the point. -20.21. What is the difference between the Primary completion rate (% of total enrollments) of World in 1999 and the Primary completion rate (% of total enrollments) of Venezuela in 2000?
Your answer should be compact. -8.86. What is the difference between the Primary completion rate (% of total enrollments) in Colombia in 1999 and the Primary completion rate (% of total enrollments) in Venezuela in 2000?
Give a very brief answer. 11.41. What is the difference between the Primary completion rate (% of total enrollments) of Central Europe in 1999 and the Primary completion rate (% of total enrollments) of World in 2002?
Your answer should be very brief. 14. What is the difference between the Primary completion rate (% of total enrollments) of Central Europe in 1999 and the Primary completion rate (% of total enrollments) of Colombia in 2002?
Offer a terse response. -0.42. What is the difference between the Primary completion rate (% of total enrollments) in Central Europe in 1999 and the Primary completion rate (% of total enrollments) in Venezuela in 2002?
Provide a short and direct response. 0.41. What is the difference between the Primary completion rate (% of total enrollments) of World in 1999 and the Primary completion rate (% of total enrollments) of Colombia in 2002?
Ensure brevity in your answer.  -17.81. What is the difference between the Primary completion rate (% of total enrollments) of World in 1999 and the Primary completion rate (% of total enrollments) of Venezuela in 2002?
Ensure brevity in your answer.  -16.98. What is the difference between the Primary completion rate (% of total enrollments) in Colombia in 1999 and the Primary completion rate (% of total enrollments) in Venezuela in 2002?
Your answer should be compact. 3.29. What is the difference between the Primary completion rate (% of total enrollments) of Central Europe in 2000 and the Primary completion rate (% of total enrollments) of World in 2002?
Offer a terse response. 13.86. What is the difference between the Primary completion rate (% of total enrollments) of Central Europe in 2000 and the Primary completion rate (% of total enrollments) of Colombia in 2002?
Offer a very short reply. -0.56. What is the difference between the Primary completion rate (% of total enrollments) of Central Europe in 2000 and the Primary completion rate (% of total enrollments) of Venezuela in 2002?
Your answer should be very brief. 0.27. What is the difference between the Primary completion rate (% of total enrollments) of World in 2000 and the Primary completion rate (% of total enrollments) of Colombia in 2002?
Give a very brief answer. -16.73. What is the difference between the Primary completion rate (% of total enrollments) of World in 2000 and the Primary completion rate (% of total enrollments) of Venezuela in 2002?
Your answer should be compact. -15.9. What is the difference between the Primary completion rate (% of total enrollments) of Colombia in 2000 and the Primary completion rate (% of total enrollments) of Venezuela in 2002?
Offer a very short reply. 3.23. What is the average Primary completion rate (% of total enrollments) of Central Europe per year?
Your answer should be very brief. 93.65. What is the average Primary completion rate (% of total enrollments) in World per year?
Keep it short and to the point. 77.5. What is the average Primary completion rate (% of total enrollments) in Colombia per year?
Your response must be concise. 87.87. What is the average Primary completion rate (% of total enrollments) in Venezuela per year?
Your answer should be very brief. 87.24. In the year 1989, what is the difference between the Primary completion rate (% of total enrollments) in Central Europe and Primary completion rate (% of total enrollments) in World?
Offer a terse response. 17.49. In the year 1989, what is the difference between the Primary completion rate (% of total enrollments) of Central Europe and Primary completion rate (% of total enrollments) of Colombia?
Your answer should be compact. 21.63. In the year 1989, what is the difference between the Primary completion rate (% of total enrollments) of Central Europe and Primary completion rate (% of total enrollments) of Venezuela?
Your response must be concise. 10.05. In the year 1989, what is the difference between the Primary completion rate (% of total enrollments) in World and Primary completion rate (% of total enrollments) in Colombia?
Your response must be concise. 4.14. In the year 1989, what is the difference between the Primary completion rate (% of total enrollments) of World and Primary completion rate (% of total enrollments) of Venezuela?
Offer a very short reply. -7.44. In the year 1989, what is the difference between the Primary completion rate (% of total enrollments) of Colombia and Primary completion rate (% of total enrollments) of Venezuela?
Provide a succinct answer. -11.58. In the year 1991, what is the difference between the Primary completion rate (% of total enrollments) of Central Europe and Primary completion rate (% of total enrollments) of World?
Offer a very short reply. 13.83. In the year 1991, what is the difference between the Primary completion rate (% of total enrollments) in Central Europe and Primary completion rate (% of total enrollments) in Colombia?
Your response must be concise. 14.74. In the year 1991, what is the difference between the Primary completion rate (% of total enrollments) in Central Europe and Primary completion rate (% of total enrollments) in Venezuela?
Keep it short and to the point. 4.91. In the year 1991, what is the difference between the Primary completion rate (% of total enrollments) of World and Primary completion rate (% of total enrollments) of Colombia?
Your answer should be very brief. 0.9. In the year 1991, what is the difference between the Primary completion rate (% of total enrollments) in World and Primary completion rate (% of total enrollments) in Venezuela?
Offer a terse response. -8.92. In the year 1991, what is the difference between the Primary completion rate (% of total enrollments) of Colombia and Primary completion rate (% of total enrollments) of Venezuela?
Provide a short and direct response. -9.83. In the year 1992, what is the difference between the Primary completion rate (% of total enrollments) of Central Europe and Primary completion rate (% of total enrollments) of World?
Your answer should be very brief. 14.72. In the year 1992, what is the difference between the Primary completion rate (% of total enrollments) in Central Europe and Primary completion rate (% of total enrollments) in Colombia?
Make the answer very short. 3.13. In the year 1992, what is the difference between the Primary completion rate (% of total enrollments) of Central Europe and Primary completion rate (% of total enrollments) of Venezuela?
Your response must be concise. 1.75. In the year 1992, what is the difference between the Primary completion rate (% of total enrollments) of World and Primary completion rate (% of total enrollments) of Colombia?
Offer a very short reply. -11.59. In the year 1992, what is the difference between the Primary completion rate (% of total enrollments) of World and Primary completion rate (% of total enrollments) of Venezuela?
Ensure brevity in your answer.  -12.97. In the year 1992, what is the difference between the Primary completion rate (% of total enrollments) in Colombia and Primary completion rate (% of total enrollments) in Venezuela?
Provide a short and direct response. -1.38. In the year 1993, what is the difference between the Primary completion rate (% of total enrollments) in Central Europe and Primary completion rate (% of total enrollments) in World?
Offer a terse response. 14.92. In the year 1993, what is the difference between the Primary completion rate (% of total enrollments) of Central Europe and Primary completion rate (% of total enrollments) of Colombia?
Provide a succinct answer. 5.77. In the year 1993, what is the difference between the Primary completion rate (% of total enrollments) of Central Europe and Primary completion rate (% of total enrollments) of Venezuela?
Provide a succinct answer. 3.71. In the year 1993, what is the difference between the Primary completion rate (% of total enrollments) of World and Primary completion rate (% of total enrollments) of Colombia?
Give a very brief answer. -9.16. In the year 1993, what is the difference between the Primary completion rate (% of total enrollments) of World and Primary completion rate (% of total enrollments) of Venezuela?
Your response must be concise. -11.21. In the year 1993, what is the difference between the Primary completion rate (% of total enrollments) in Colombia and Primary completion rate (% of total enrollments) in Venezuela?
Give a very brief answer. -2.06. In the year 1996, what is the difference between the Primary completion rate (% of total enrollments) in Central Europe and Primary completion rate (% of total enrollments) in World?
Provide a succinct answer. 18.77. In the year 1996, what is the difference between the Primary completion rate (% of total enrollments) in Central Europe and Primary completion rate (% of total enrollments) in Colombia?
Provide a succinct answer. 5.36. In the year 1996, what is the difference between the Primary completion rate (% of total enrollments) of Central Europe and Primary completion rate (% of total enrollments) of Venezuela?
Give a very brief answer. 10.13. In the year 1996, what is the difference between the Primary completion rate (% of total enrollments) in World and Primary completion rate (% of total enrollments) in Colombia?
Provide a short and direct response. -13.41. In the year 1996, what is the difference between the Primary completion rate (% of total enrollments) of World and Primary completion rate (% of total enrollments) of Venezuela?
Your answer should be very brief. -8.64. In the year 1996, what is the difference between the Primary completion rate (% of total enrollments) in Colombia and Primary completion rate (% of total enrollments) in Venezuela?
Your response must be concise. 4.77. In the year 1999, what is the difference between the Primary completion rate (% of total enrollments) in Central Europe and Primary completion rate (% of total enrollments) in World?
Keep it short and to the point. 17.39. In the year 1999, what is the difference between the Primary completion rate (% of total enrollments) of Central Europe and Primary completion rate (% of total enrollments) of Colombia?
Ensure brevity in your answer.  -2.88. In the year 1999, what is the difference between the Primary completion rate (% of total enrollments) of Central Europe and Primary completion rate (% of total enrollments) of Venezuela?
Keep it short and to the point. 10.02. In the year 1999, what is the difference between the Primary completion rate (% of total enrollments) of World and Primary completion rate (% of total enrollments) of Colombia?
Offer a very short reply. -20.27. In the year 1999, what is the difference between the Primary completion rate (% of total enrollments) in World and Primary completion rate (% of total enrollments) in Venezuela?
Your answer should be very brief. -7.38. In the year 1999, what is the difference between the Primary completion rate (% of total enrollments) in Colombia and Primary completion rate (% of total enrollments) in Venezuela?
Offer a very short reply. 12.89. In the year 2000, what is the difference between the Primary completion rate (% of total enrollments) of Central Europe and Primary completion rate (% of total enrollments) of World?
Make the answer very short. 16.17. In the year 2000, what is the difference between the Primary completion rate (% of total enrollments) in Central Europe and Primary completion rate (% of total enrollments) in Colombia?
Your response must be concise. -2.97. In the year 2000, what is the difference between the Primary completion rate (% of total enrollments) of Central Europe and Primary completion rate (% of total enrollments) of Venezuela?
Offer a very short reply. 8.39. In the year 2000, what is the difference between the Primary completion rate (% of total enrollments) in World and Primary completion rate (% of total enrollments) in Colombia?
Make the answer very short. -19.13. In the year 2000, what is the difference between the Primary completion rate (% of total enrollments) in World and Primary completion rate (% of total enrollments) in Venezuela?
Give a very brief answer. -7.77. In the year 2000, what is the difference between the Primary completion rate (% of total enrollments) in Colombia and Primary completion rate (% of total enrollments) in Venezuela?
Make the answer very short. 11.36. In the year 2002, what is the difference between the Primary completion rate (% of total enrollments) in Central Europe and Primary completion rate (% of total enrollments) in World?
Keep it short and to the point. 15.87. In the year 2002, what is the difference between the Primary completion rate (% of total enrollments) in Central Europe and Primary completion rate (% of total enrollments) in Colombia?
Your response must be concise. 1.45. In the year 2002, what is the difference between the Primary completion rate (% of total enrollments) of Central Europe and Primary completion rate (% of total enrollments) of Venezuela?
Your answer should be very brief. 2.28. In the year 2002, what is the difference between the Primary completion rate (% of total enrollments) in World and Primary completion rate (% of total enrollments) in Colombia?
Give a very brief answer. -14.42. In the year 2002, what is the difference between the Primary completion rate (% of total enrollments) in World and Primary completion rate (% of total enrollments) in Venezuela?
Offer a terse response. -13.59. In the year 2002, what is the difference between the Primary completion rate (% of total enrollments) of Colombia and Primary completion rate (% of total enrollments) of Venezuela?
Offer a terse response. 0.83. What is the ratio of the Primary completion rate (% of total enrollments) of Central Europe in 1989 to that in 1991?
Make the answer very short. 1.03. What is the ratio of the Primary completion rate (% of total enrollments) of World in 1989 to that in 1991?
Your answer should be very brief. 0.99. What is the ratio of the Primary completion rate (% of total enrollments) of Colombia in 1989 to that in 1991?
Offer a very short reply. 0.95. What is the ratio of the Primary completion rate (% of total enrollments) of Venezuela in 1989 to that in 1991?
Give a very brief answer. 0.98. What is the ratio of the Primary completion rate (% of total enrollments) in Central Europe in 1989 to that in 1992?
Give a very brief answer. 1.03. What is the ratio of the Primary completion rate (% of total enrollments) of World in 1989 to that in 1992?
Your answer should be compact. 1. What is the ratio of the Primary completion rate (% of total enrollments) in Colombia in 1989 to that in 1992?
Your answer should be very brief. 0.82. What is the ratio of the Primary completion rate (% of total enrollments) of Venezuela in 1989 to that in 1992?
Keep it short and to the point. 0.94. What is the ratio of the Primary completion rate (% of total enrollments) in Central Europe in 1989 to that in 1993?
Make the answer very short. 1.02. What is the ratio of the Primary completion rate (% of total enrollments) of World in 1989 to that in 1993?
Offer a terse response. 0.99. What is the ratio of the Primary completion rate (% of total enrollments) in Colombia in 1989 to that in 1993?
Give a very brief answer. 0.84. What is the ratio of the Primary completion rate (% of total enrollments) of Venezuela in 1989 to that in 1993?
Provide a short and direct response. 0.95. What is the ratio of the Primary completion rate (% of total enrollments) of Central Europe in 1989 to that in 1996?
Ensure brevity in your answer.  0.99. What is the ratio of the Primary completion rate (% of total enrollments) of Colombia in 1989 to that in 1996?
Offer a very short reply. 0.81. What is the ratio of the Primary completion rate (% of total enrollments) of Venezuela in 1989 to that in 1996?
Offer a terse response. 0.99. What is the ratio of the Primary completion rate (% of total enrollments) in World in 1989 to that in 1999?
Give a very brief answer. 0.99. What is the ratio of the Primary completion rate (% of total enrollments) of Colombia in 1989 to that in 1999?
Provide a short and direct response. 0.74. What is the ratio of the Primary completion rate (% of total enrollments) in Venezuela in 1989 to that in 1999?
Your answer should be compact. 0.99. What is the ratio of the Primary completion rate (% of total enrollments) of World in 1989 to that in 2000?
Provide a short and direct response. 0.98. What is the ratio of the Primary completion rate (% of total enrollments) in Colombia in 1989 to that in 2000?
Make the answer very short. 0.74. What is the ratio of the Primary completion rate (% of total enrollments) of Venezuela in 1989 to that in 2000?
Offer a terse response. 0.98. What is the ratio of the Primary completion rate (% of total enrollments) in Central Europe in 1989 to that in 2002?
Your answer should be compact. 0.98. What is the ratio of the Primary completion rate (% of total enrollments) of World in 1989 to that in 2002?
Offer a very short reply. 0.95. What is the ratio of the Primary completion rate (% of total enrollments) in Colombia in 1989 to that in 2002?
Offer a terse response. 0.76. What is the ratio of the Primary completion rate (% of total enrollments) in Venezuela in 1989 to that in 2002?
Offer a very short reply. 0.89. What is the ratio of the Primary completion rate (% of total enrollments) of World in 1991 to that in 1992?
Ensure brevity in your answer.  1.01. What is the ratio of the Primary completion rate (% of total enrollments) in Colombia in 1991 to that in 1992?
Your response must be concise. 0.86. What is the ratio of the Primary completion rate (% of total enrollments) of Venezuela in 1991 to that in 1992?
Offer a terse response. 0.96. What is the ratio of the Primary completion rate (% of total enrollments) of Central Europe in 1991 to that in 1993?
Make the answer very short. 0.98. What is the ratio of the Primary completion rate (% of total enrollments) of Colombia in 1991 to that in 1993?
Offer a very short reply. 0.88. What is the ratio of the Primary completion rate (% of total enrollments) of Venezuela in 1991 to that in 1993?
Your answer should be very brief. 0.97. What is the ratio of the Primary completion rate (% of total enrollments) in Central Europe in 1991 to that in 1996?
Your answer should be compact. 0.96. What is the ratio of the Primary completion rate (% of total enrollments) in World in 1991 to that in 1996?
Your answer should be very brief. 1.01. What is the ratio of the Primary completion rate (% of total enrollments) in Colombia in 1991 to that in 1996?
Make the answer very short. 0.85. What is the ratio of the Primary completion rate (% of total enrollments) in Venezuela in 1991 to that in 1996?
Give a very brief answer. 1.01. What is the ratio of the Primary completion rate (% of total enrollments) in Central Europe in 1991 to that in 1999?
Provide a succinct answer. 0.96. What is the ratio of the Primary completion rate (% of total enrollments) in Colombia in 1991 to that in 1999?
Provide a short and direct response. 0.78. What is the ratio of the Primary completion rate (% of total enrollments) in Venezuela in 1991 to that in 1999?
Your answer should be very brief. 1.02. What is the ratio of the Primary completion rate (% of total enrollments) in Central Europe in 1991 to that in 2000?
Offer a very short reply. 0.96. What is the ratio of the Primary completion rate (% of total enrollments) of World in 1991 to that in 2000?
Make the answer very short. 0.99. What is the ratio of the Primary completion rate (% of total enrollments) of Colombia in 1991 to that in 2000?
Provide a short and direct response. 0.78. What is the ratio of the Primary completion rate (% of total enrollments) in Central Europe in 1991 to that in 2002?
Offer a very short reply. 0.94. What is the ratio of the Primary completion rate (% of total enrollments) of World in 1991 to that in 2002?
Your response must be concise. 0.96. What is the ratio of the Primary completion rate (% of total enrollments) in Colombia in 1991 to that in 2002?
Give a very brief answer. 0.8. What is the ratio of the Primary completion rate (% of total enrollments) in Venezuela in 1991 to that in 2002?
Offer a terse response. 0.91. What is the ratio of the Primary completion rate (% of total enrollments) of Central Europe in 1992 to that in 1993?
Provide a short and direct response. 0.99. What is the ratio of the Primary completion rate (% of total enrollments) in World in 1992 to that in 1993?
Offer a terse response. 0.99. What is the ratio of the Primary completion rate (% of total enrollments) in Colombia in 1992 to that in 1993?
Offer a terse response. 1.02. What is the ratio of the Primary completion rate (% of total enrollments) of Venezuela in 1992 to that in 1993?
Give a very brief answer. 1.01. What is the ratio of the Primary completion rate (% of total enrollments) in Central Europe in 1992 to that in 1996?
Provide a short and direct response. 0.96. What is the ratio of the Primary completion rate (% of total enrollments) in Colombia in 1992 to that in 1996?
Ensure brevity in your answer.  0.98. What is the ratio of the Primary completion rate (% of total enrollments) of Venezuela in 1992 to that in 1996?
Make the answer very short. 1.05. What is the ratio of the Primary completion rate (% of total enrollments) in Colombia in 1992 to that in 1999?
Give a very brief answer. 0.91. What is the ratio of the Primary completion rate (% of total enrollments) in Venezuela in 1992 to that in 1999?
Your answer should be very brief. 1.06. What is the ratio of the Primary completion rate (% of total enrollments) of Central Europe in 1992 to that in 2000?
Your response must be concise. 0.97. What is the ratio of the Primary completion rate (% of total enrollments) of World in 1992 to that in 2000?
Your answer should be compact. 0.98. What is the ratio of the Primary completion rate (% of total enrollments) in Colombia in 1992 to that in 2000?
Your answer should be very brief. 0.91. What is the ratio of the Primary completion rate (% of total enrollments) in Venezuela in 1992 to that in 2000?
Offer a terse response. 1.04. What is the ratio of the Primary completion rate (% of total enrollments) in Central Europe in 1992 to that in 2002?
Offer a very short reply. 0.95. What is the ratio of the Primary completion rate (% of total enrollments) in World in 1992 to that in 2002?
Keep it short and to the point. 0.95. What is the ratio of the Primary completion rate (% of total enrollments) in Colombia in 1992 to that in 2002?
Provide a short and direct response. 0.93. What is the ratio of the Primary completion rate (% of total enrollments) of Venezuela in 1992 to that in 2002?
Offer a very short reply. 0.95. What is the ratio of the Primary completion rate (% of total enrollments) in Central Europe in 1993 to that in 1996?
Keep it short and to the point. 0.97. What is the ratio of the Primary completion rate (% of total enrollments) in World in 1993 to that in 1996?
Make the answer very short. 1.01. What is the ratio of the Primary completion rate (% of total enrollments) of Colombia in 1993 to that in 1996?
Offer a very short reply. 0.96. What is the ratio of the Primary completion rate (% of total enrollments) in Venezuela in 1993 to that in 1996?
Provide a succinct answer. 1.04. What is the ratio of the Primary completion rate (% of total enrollments) of Central Europe in 1993 to that in 1999?
Give a very brief answer. 0.98. What is the ratio of the Primary completion rate (% of total enrollments) in World in 1993 to that in 1999?
Provide a succinct answer. 1. What is the ratio of the Primary completion rate (% of total enrollments) in Colombia in 1993 to that in 1999?
Provide a succinct answer. 0.89. What is the ratio of the Primary completion rate (% of total enrollments) in Venezuela in 1993 to that in 1999?
Ensure brevity in your answer.  1.05. What is the ratio of the Primary completion rate (% of total enrollments) in Central Europe in 1993 to that in 2000?
Your answer should be very brief. 0.98. What is the ratio of the Primary completion rate (% of total enrollments) of World in 1993 to that in 2000?
Ensure brevity in your answer.  0.99. What is the ratio of the Primary completion rate (% of total enrollments) in Colombia in 1993 to that in 2000?
Keep it short and to the point. 0.89. What is the ratio of the Primary completion rate (% of total enrollments) of Venezuela in 1993 to that in 2000?
Ensure brevity in your answer.  1.03. What is the ratio of the Primary completion rate (% of total enrollments) of Central Europe in 1993 to that in 2002?
Offer a terse response. 0.96. What is the ratio of the Primary completion rate (% of total enrollments) in World in 1993 to that in 2002?
Provide a succinct answer. 0.96. What is the ratio of the Primary completion rate (% of total enrollments) of Colombia in 1993 to that in 2002?
Make the answer very short. 0.91. What is the ratio of the Primary completion rate (% of total enrollments) of Venezuela in 1993 to that in 2002?
Your answer should be compact. 0.94. What is the ratio of the Primary completion rate (% of total enrollments) of Central Europe in 1996 to that in 1999?
Your answer should be very brief. 1.01. What is the ratio of the Primary completion rate (% of total enrollments) in World in 1996 to that in 1999?
Provide a succinct answer. 0.99. What is the ratio of the Primary completion rate (% of total enrollments) in Colombia in 1996 to that in 1999?
Offer a terse response. 0.92. What is the ratio of the Primary completion rate (% of total enrollments) in Venezuela in 1996 to that in 1999?
Provide a short and direct response. 1.01. What is the ratio of the Primary completion rate (% of total enrollments) in Central Europe in 1996 to that in 2000?
Make the answer very short. 1.01. What is the ratio of the Primary completion rate (% of total enrollments) of World in 1996 to that in 2000?
Keep it short and to the point. 0.98. What is the ratio of the Primary completion rate (% of total enrollments) in Colombia in 1996 to that in 2000?
Keep it short and to the point. 0.92. What is the ratio of the Primary completion rate (% of total enrollments) in Central Europe in 1996 to that in 2002?
Provide a short and direct response. 0.99. What is the ratio of the Primary completion rate (% of total enrollments) of World in 1996 to that in 2002?
Offer a terse response. 0.95. What is the ratio of the Primary completion rate (% of total enrollments) in Colombia in 1996 to that in 2002?
Keep it short and to the point. 0.95. What is the ratio of the Primary completion rate (% of total enrollments) in Venezuela in 1996 to that in 2002?
Provide a short and direct response. 0.9. What is the ratio of the Primary completion rate (% of total enrollments) of World in 1999 to that in 2000?
Your answer should be compact. 0.99. What is the ratio of the Primary completion rate (% of total enrollments) in Venezuela in 1999 to that in 2000?
Give a very brief answer. 0.98. What is the ratio of the Primary completion rate (% of total enrollments) in Central Europe in 1999 to that in 2002?
Offer a very short reply. 0.98. What is the ratio of the Primary completion rate (% of total enrollments) of World in 1999 to that in 2002?
Make the answer very short. 0.96. What is the ratio of the Primary completion rate (% of total enrollments) of Colombia in 1999 to that in 2002?
Provide a succinct answer. 1.03. What is the ratio of the Primary completion rate (% of total enrollments) in Venezuela in 1999 to that in 2002?
Ensure brevity in your answer.  0.9. What is the ratio of the Primary completion rate (% of total enrollments) of Central Europe in 2000 to that in 2002?
Your response must be concise. 0.98. What is the ratio of the Primary completion rate (% of total enrollments) of World in 2000 to that in 2002?
Your answer should be very brief. 0.97. What is the ratio of the Primary completion rate (% of total enrollments) in Colombia in 2000 to that in 2002?
Your answer should be compact. 1.03. What is the ratio of the Primary completion rate (% of total enrollments) of Venezuela in 2000 to that in 2002?
Your response must be concise. 0.91. What is the difference between the highest and the second highest Primary completion rate (% of total enrollments) of Central Europe?
Your answer should be very brief. 1.18. What is the difference between the highest and the second highest Primary completion rate (% of total enrollments) of World?
Offer a very short reply. 2.31. What is the difference between the highest and the second highest Primary completion rate (% of total enrollments) of Colombia?
Your answer should be very brief. 0.06. What is the difference between the highest and the second highest Primary completion rate (% of total enrollments) in Venezuela?
Provide a succinct answer. 4.39. What is the difference between the highest and the lowest Primary completion rate (% of total enrollments) of Central Europe?
Keep it short and to the point. 5.39. What is the difference between the highest and the lowest Primary completion rate (% of total enrollments) of World?
Your answer should be very brief. 4.07. What is the difference between the highest and the lowest Primary completion rate (% of total enrollments) in Colombia?
Give a very brief answer. 25.01. What is the difference between the highest and the lowest Primary completion rate (% of total enrollments) of Venezuela?
Offer a terse response. 10.14. 